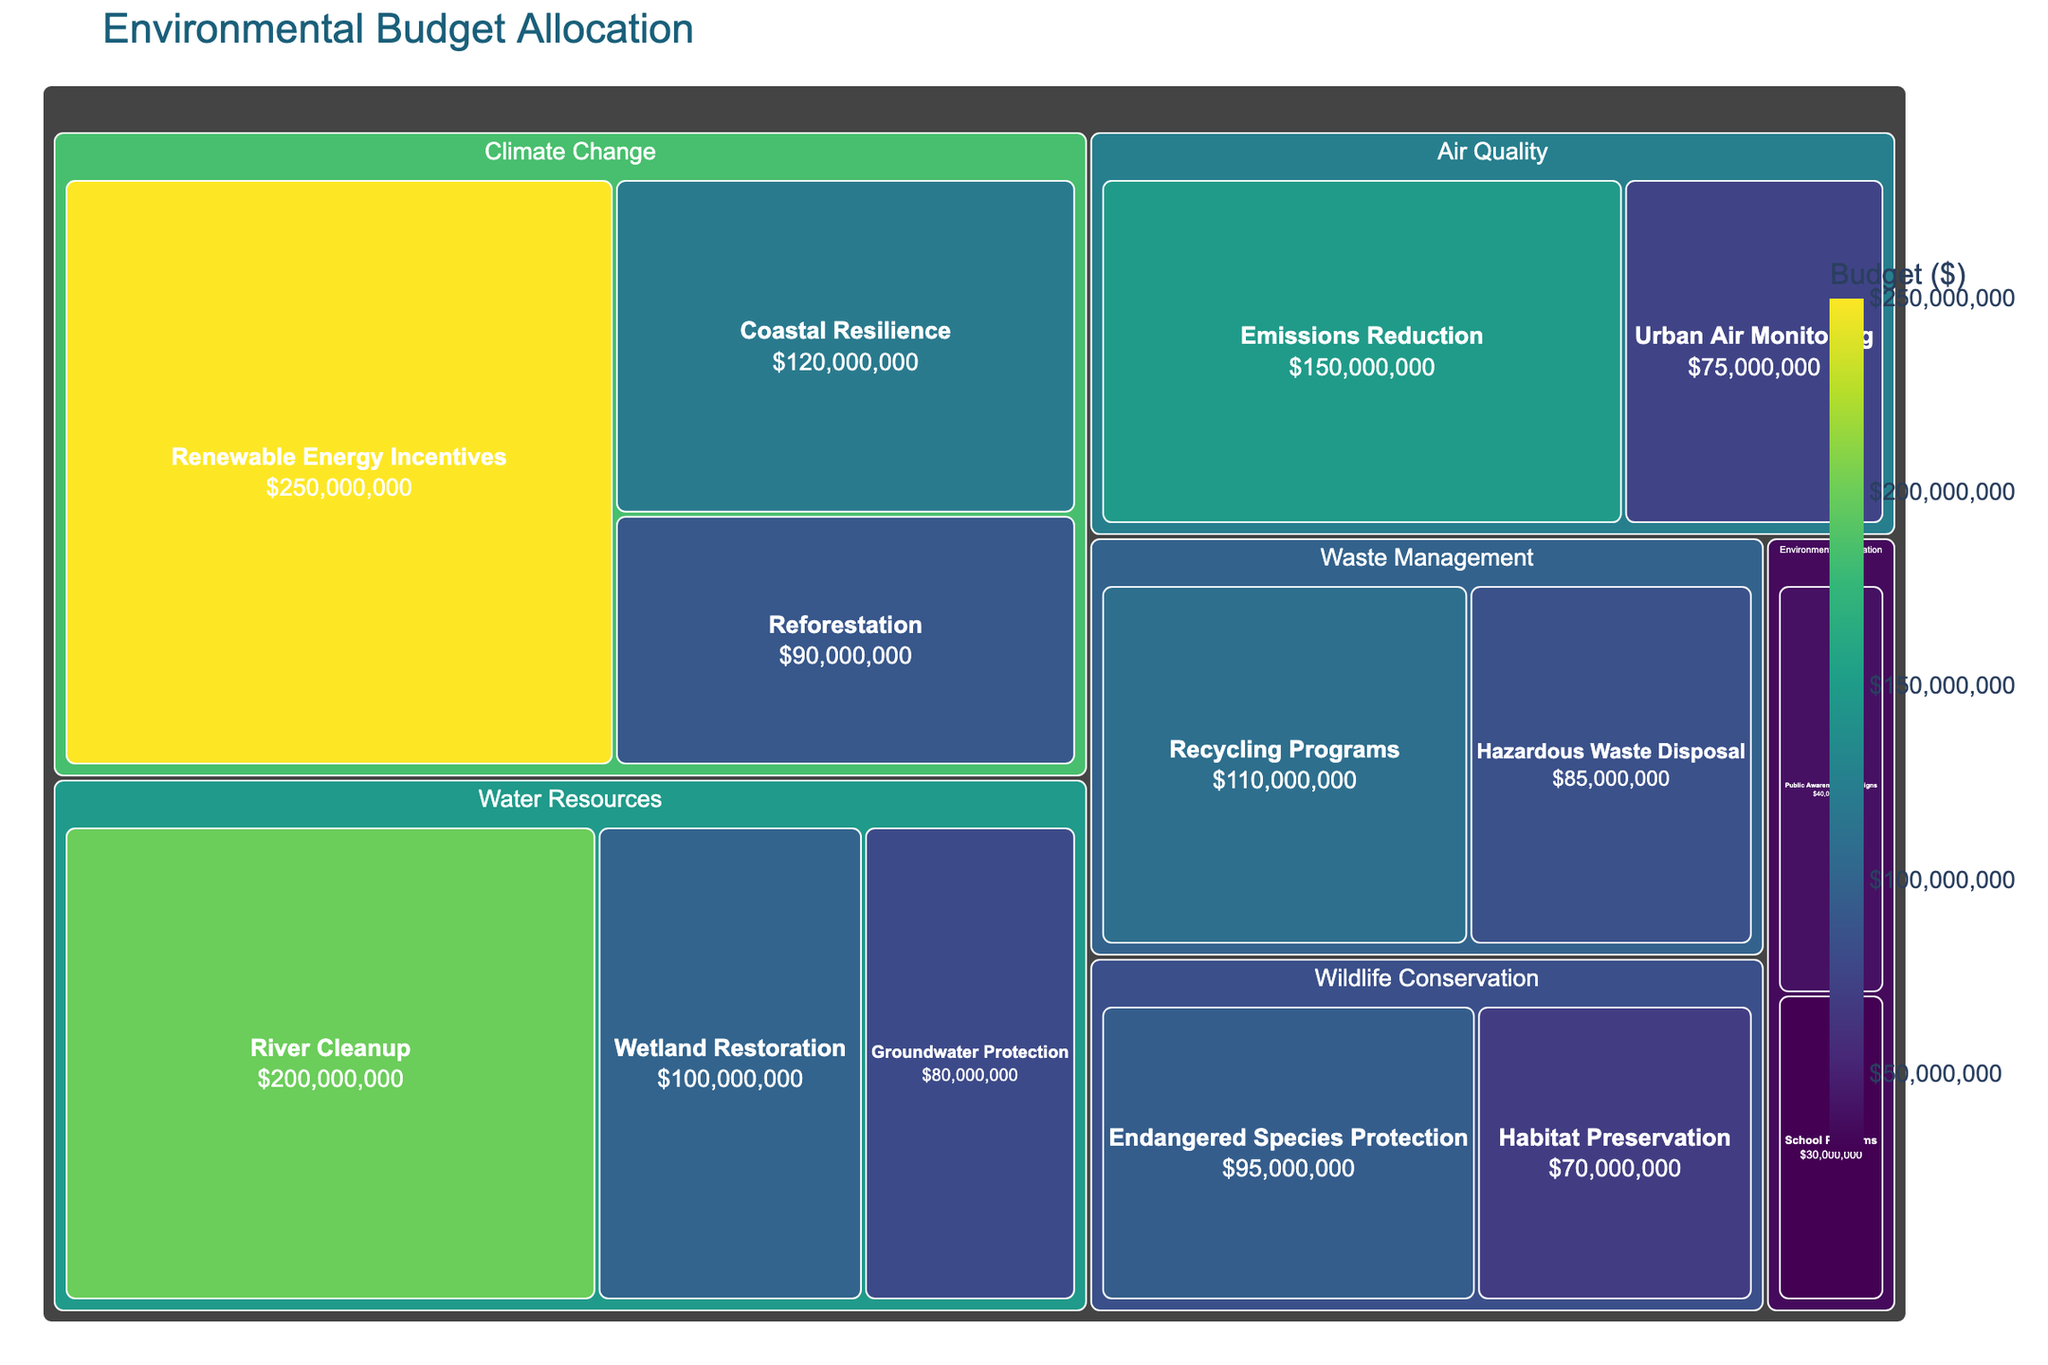What is the title of the treemap figure? The title is prominently displayed at the top of the figure.
Answer: Environmental Budget Allocation Which category has the highest total budget allocation? By inspecting the relative sizes of the categories in the treemap, the "Climate Change" category has the largest area, indicating the highest overall budget.
Answer: Climate Change What is the budget allocated to Urban Air Monitoring? Look for the "Urban Air Monitoring" subcategory in the "Air Quality" category. The budget value is displayed within its rectangle.
Answer: $75,000,000 How many subcategories are there under the Water Resources category? Each subcategory is shown within the "Water Resources" category. Count these subcategories.
Answer: 3 What is the combined budget for Renewable Energy Incentives and Reforestation? Add the budget values for "Renewable Energy Incentives" ($250,000,000) and "Reforestation" ($90,000,000).
Answer: $340,000,000 Which subcategory in Waste Management has a lower budget allocation? Compare the budget allocations of "Recycling Programs" ($110,000,000) and "Hazardous Waste Disposal" ($85,000,000). The smaller value indicates the subcategory with a lower budget.
Answer: Hazardous Waste Disposal How much more is allocated to River Cleanup than to Wetland Restoration? Subtract the budget of "Wetland Restoration" ($100,000,000) from the budget of "River Cleanup" ($200,000,000).
Answer: $100,000,000 What colors represent the highest and lowest budget allocations in the treemap? Darker or more saturated colors typically represent higher values, while lighter or less saturated colors represent lower values. Viridis color scale is used to determine this.
Answer: Highest: Dark yellow-green, Lowest: Dark purple Compared to Endangered Species Protection, is Groundwater Protection's budget higher, lower, or equal? Compare the budget values in the respective subcategories. "Endangered Species Protection" has a budget of $95,000,000 and "Groundwater Protection" has $80,000,000.
Answer: Lower What is the average budget allocation for subcategories in the Climate Change category? Sum the budgets for "Renewable Energy Incentives" ($250,000,000), "Coastal Resilience" ($120,000,000), and "Reforestation" ($90,000,000), then divide by the number of subcategories (3). \( (250000000 + 120000000 + 90000000) / 3 = 153333333.33 \)
Answer: $153,333,333.33 